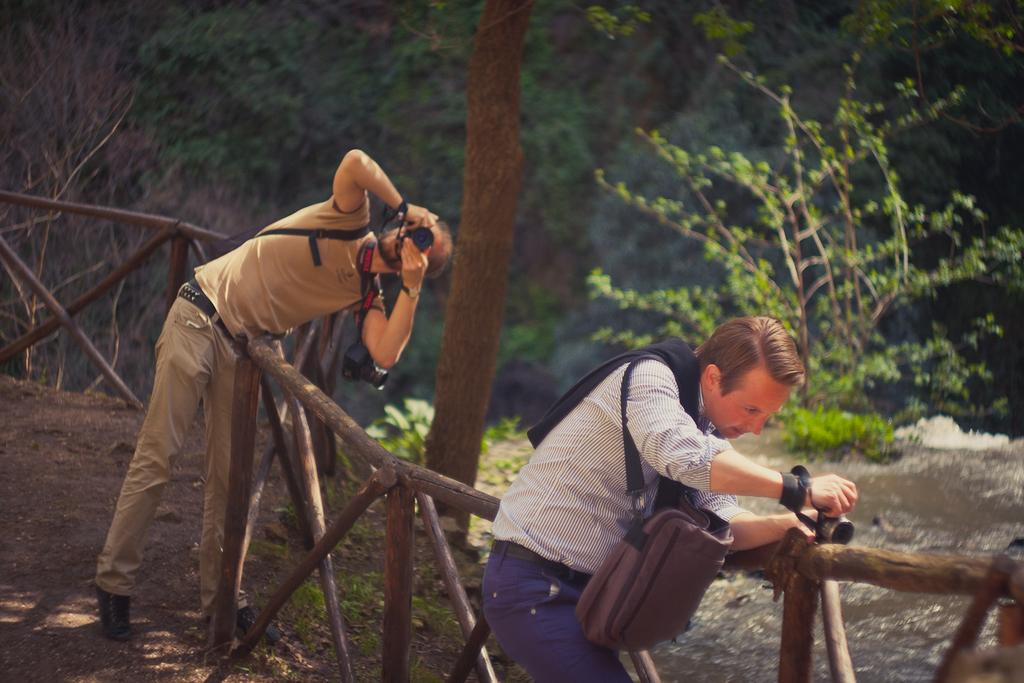How many people are in the image? There are two persons in the image. What are the persons doing in the image? The persons are standing and holding cameras in their hands. What can be seen in the background of the image? There is water and trees visible in the background. What type of fencing is present in the image? There is wooden fencing in the image. What type of advertisement can be seen on the train in the image? There are no trains present in the image, so there cannot be an advertisement on a train. 